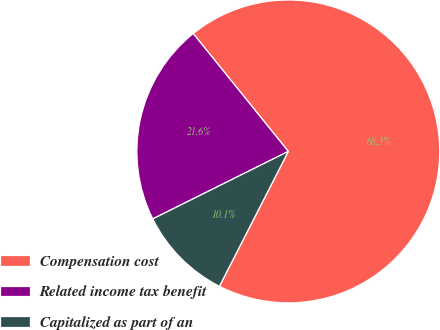Convert chart to OTSL. <chart><loc_0><loc_0><loc_500><loc_500><pie_chart><fcel>Compensation cost<fcel>Related income tax benefit<fcel>Capitalized as part of an<nl><fcel>68.32%<fcel>21.55%<fcel>10.13%<nl></chart> 